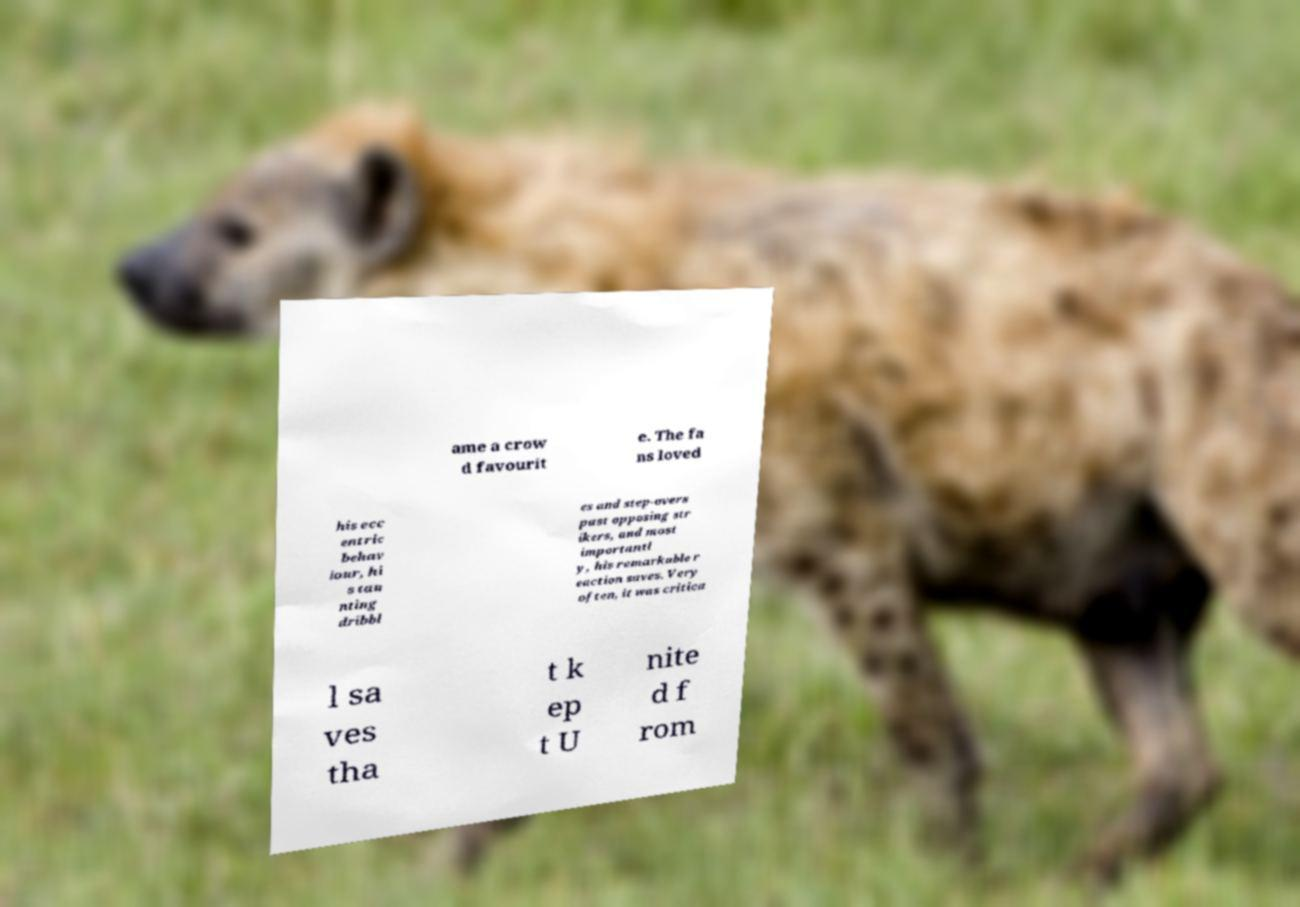Could you assist in decoding the text presented in this image and type it out clearly? ame a crow d favourit e. The fa ns loved his ecc entric behav iour, hi s tau nting dribbl es and step-overs past opposing str ikers, and most importantl y, his remarkable r eaction saves. Very often, it was critica l sa ves tha t k ep t U nite d f rom 